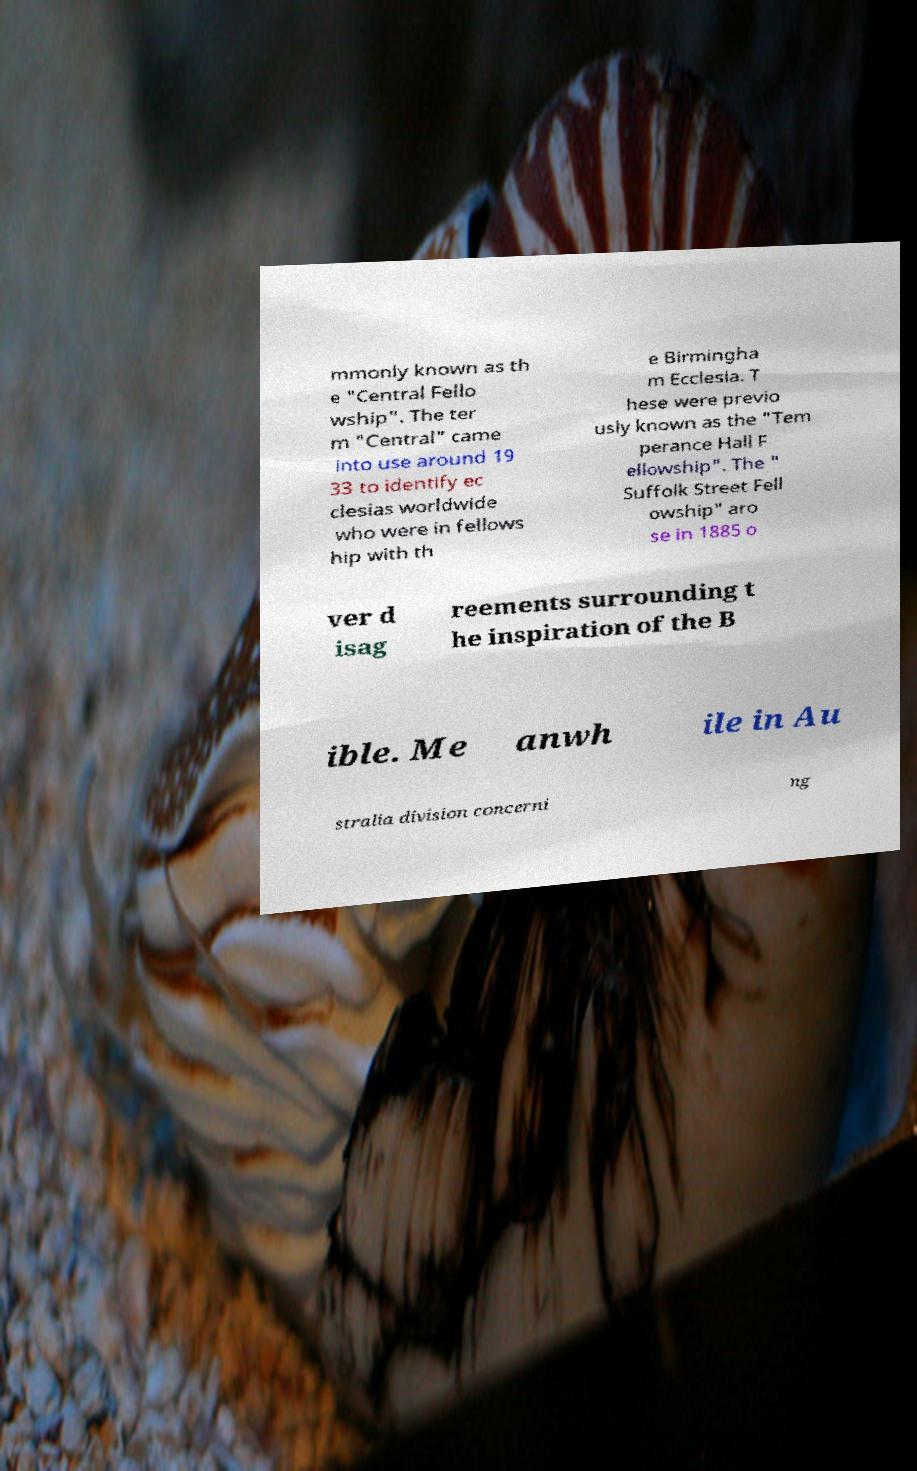Can you read and provide the text displayed in the image?This photo seems to have some interesting text. Can you extract and type it out for me? mmonly known as th e "Central Fello wship". The ter m "Central" came into use around 19 33 to identify ec clesias worldwide who were in fellows hip with th e Birmingha m Ecclesia. T hese were previo usly known as the "Tem perance Hall F ellowship". The " Suffolk Street Fell owship" aro se in 1885 o ver d isag reements surrounding t he inspiration of the B ible. Me anwh ile in Au stralia division concerni ng 